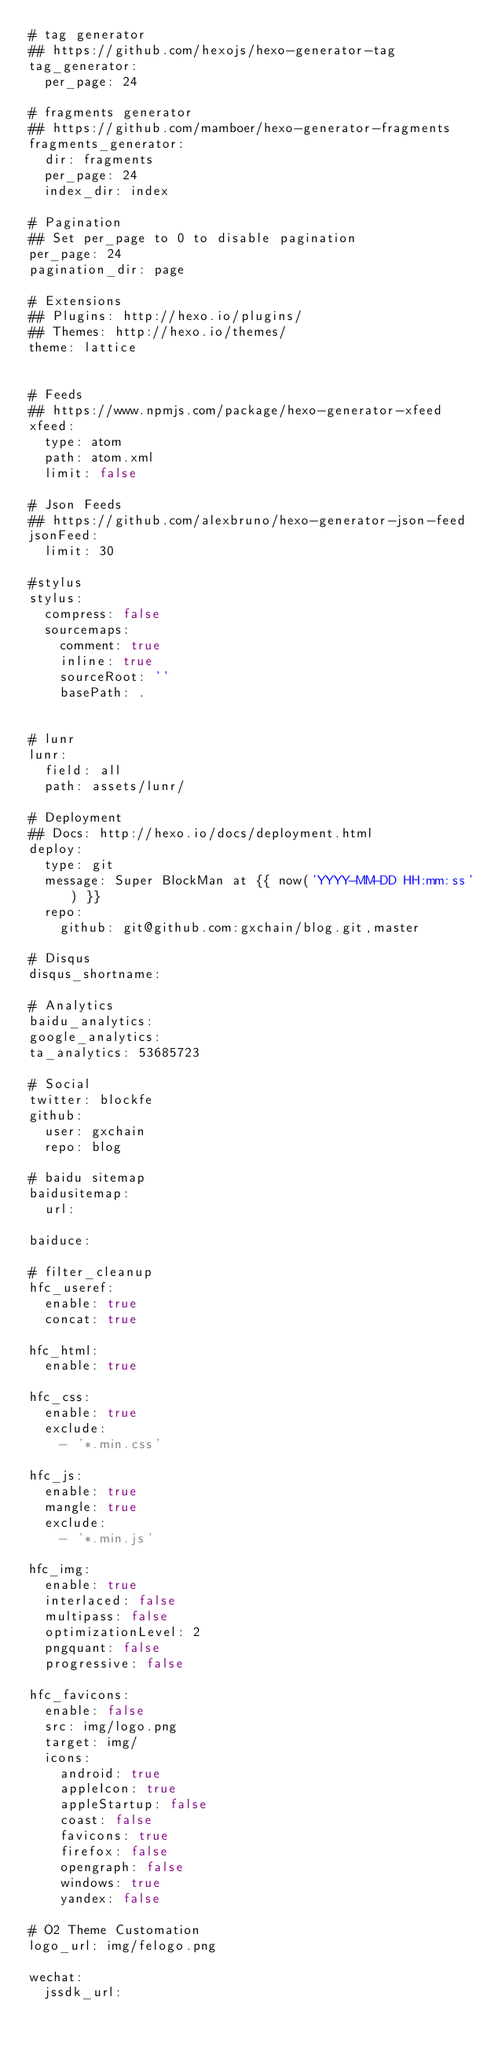Convert code to text. <code><loc_0><loc_0><loc_500><loc_500><_YAML_># tag generator
## https://github.com/hexojs/hexo-generator-tag
tag_generator:
  per_page: 24

# fragments generator
## https://github.com/mamboer/hexo-generator-fragments
fragments_generator:
  dir: fragments
  per_page: 24
  index_dir: index

# Pagination
## Set per_page to 0 to disable pagination
per_page: 24
pagination_dir: page

# Extensions
## Plugins: http://hexo.io/plugins/
## Themes: http://hexo.io/themes/
theme: lattice


# Feeds
## https://www.npmjs.com/package/hexo-generator-xfeed
xfeed:
  type: atom
  path: atom.xml
  limit: false

# Json Feeds
## https://github.com/alexbruno/hexo-generator-json-feed
jsonFeed:
  limit: 30

#stylus
stylus:
  compress: false
  sourcemaps:
    comment: true
    inline: true
    sourceRoot: ''
    basePath: .


# lunr
lunr:
  field: all
  path: assets/lunr/

# Deployment
## Docs: http://hexo.io/docs/deployment.html
deploy:
  type: git
  message: Super BlockMan at {{ now('YYYY-MM-DD HH:mm:ss') }}
  repo: 
    github: git@github.com:gxchain/blog.git,master

# Disqus
disqus_shortname:

# Analytics
baidu_analytics: 
google_analytics:
ta_analytics: 53685723

# Social
twitter: blockfe
github:
  user: gxchain
  repo: blog

# baidu sitemap
baidusitemap:
  url: 

baiduce: 

# filter_cleanup
hfc_useref:
  enable: true
  concat: true

hfc_html:
  enable: true

hfc_css:
  enable: true
  exclude: 
    - '*.min.css'

hfc_js:
  enable: true
  mangle: true
  exclude: 
    - '*.min.js'

hfc_img:
  enable: true
  interlaced: false
  multipass: false
  optimizationLevel: 2
  pngquant: false
  progressive: false

hfc_favicons:
  enable: false
  src: img/logo.png
  target: img/
  icons:
    android: true
    appleIcon: true
    appleStartup: false
    coast: false
    favicons: true
    firefox: false
    opengraph: false
    windows: true
    yandex: false

# O2 Theme Customation
logo_url: img/felogo.png

wechat:
  jssdk_url: 
</code> 